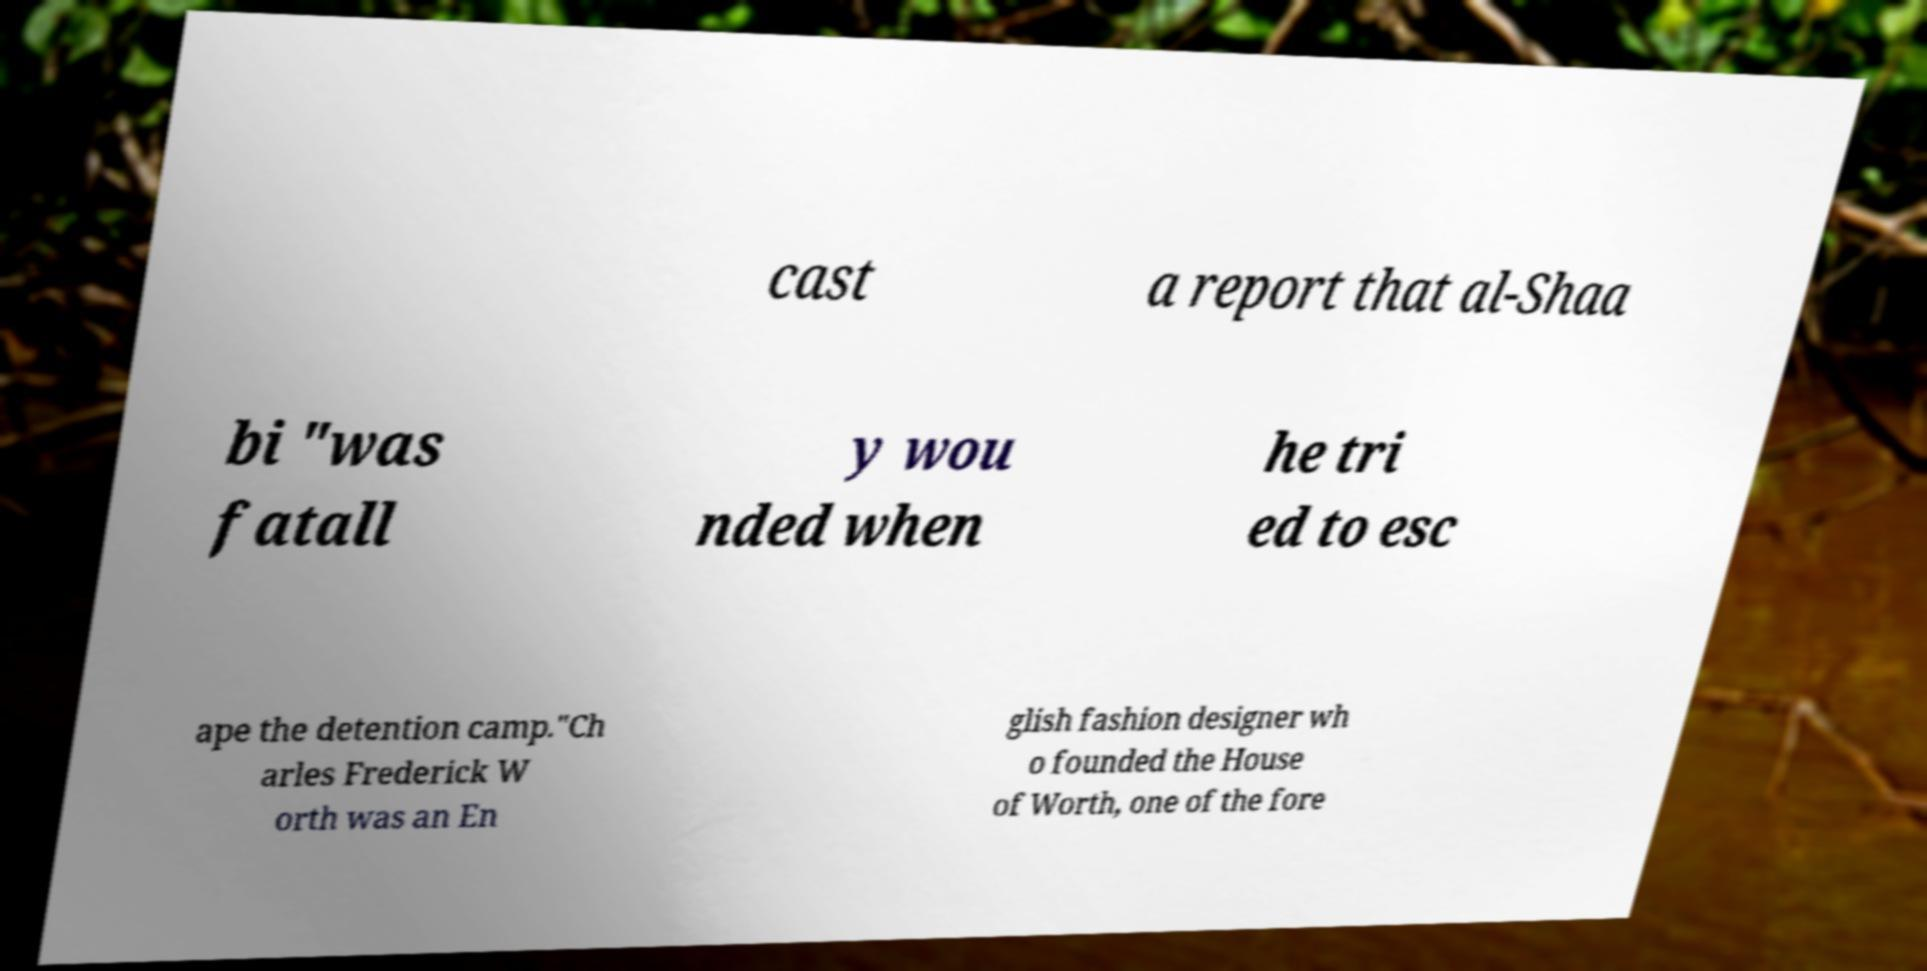Can you read and provide the text displayed in the image?This photo seems to have some interesting text. Can you extract and type it out for me? cast a report that al-Shaa bi "was fatall y wou nded when he tri ed to esc ape the detention camp."Ch arles Frederick W orth was an En glish fashion designer wh o founded the House of Worth, one of the fore 